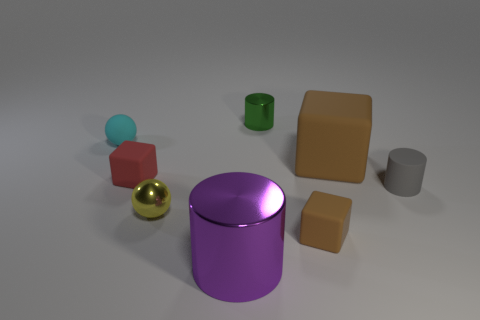How many big objects are either brown matte blocks or cyan cubes?
Ensure brevity in your answer.  1. What is the color of the other tiny object that is the same shape as the cyan thing?
Make the answer very short. Yellow. Is the size of the green metal cylinder the same as the gray cylinder?
Keep it short and to the point. Yes. How many objects are blue cubes or brown cubes that are in front of the tiny yellow metallic sphere?
Offer a very short reply. 1. What color is the small metal thing that is in front of the small cylinder on the left side of the tiny rubber cylinder?
Your answer should be compact. Yellow. Do the rubber object that is in front of the gray rubber object and the tiny matte cylinder have the same color?
Your response must be concise. No. There is a large thing that is behind the purple shiny object; what is its material?
Offer a terse response. Rubber. The red cube is what size?
Give a very brief answer. Small. Is the thing behind the cyan rubber sphere made of the same material as the yellow ball?
Your answer should be compact. Yes. What number of small blue blocks are there?
Make the answer very short. 0. 